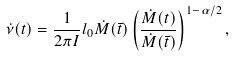Convert formula to latex. <formula><loc_0><loc_0><loc_500><loc_500>\dot { \nu } ( t ) = \frac { 1 } { 2 \pi I } l _ { 0 } \dot { M } ( \bar { t } ) \left ( \frac { \dot { M } ( t ) } { \dot { M } ( \bar { t } ) } \right ) ^ { 1 - \alpha / 2 } ,</formula> 